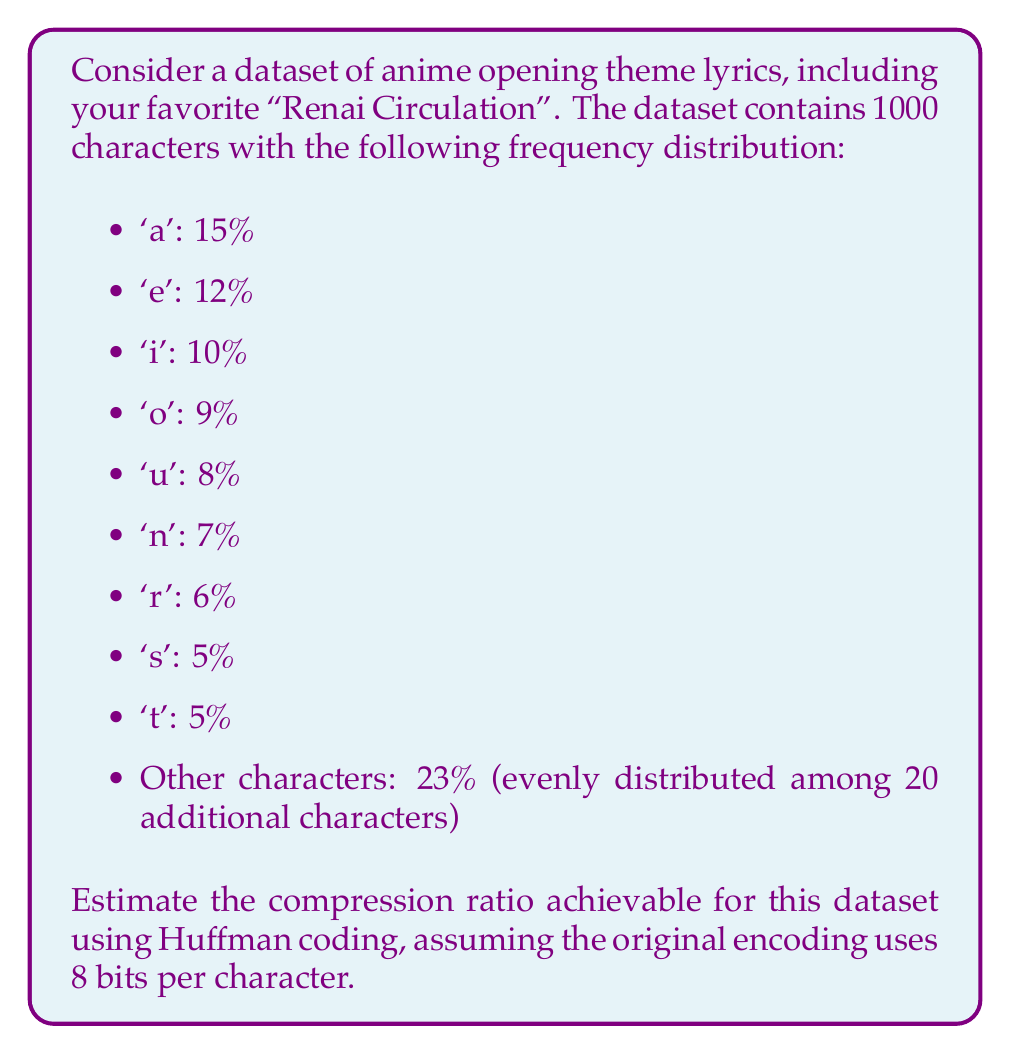Could you help me with this problem? To solve this problem, we'll follow these steps:

1. Calculate the entropy of the dataset
2. Estimate the average codeword length using Huffman coding
3. Calculate the compression ratio

Step 1: Calculate the entropy

The entropy $H$ of the dataset is given by:

$$H = -\sum_{i=1}^{n} p_i \log_2(p_i)$$

Where $p_i$ is the probability of each character.

$$\begin{align}
H &= -(0.15 \log_2(0.15) + 0.12 \log_2(0.12) + 0.10 \log_2(0.10) + 0.09 \log_2(0.09) + 0.08 \log_2(0.08) \\
&+ 0.07 \log_2(0.07) + 0.06 \log_2(0.06) + 0.05 \log_2(0.05) + 0.05 \log_2(0.05) + 20 \cdot (0.0115 \log_2(0.0115))) \\
&\approx 4.14 \text{ bits}
\end{align}$$

Step 2: Estimate average codeword length

For Huffman coding, the average codeword length is typically within 1 bit of the entropy. We'll estimate it as $H + 0.5$:

Average codeword length $\approx 4.14 + 0.5 = 4.64$ bits

Step 3: Calculate compression ratio

The compression ratio is calculated as:

$$\text{Compression Ratio} = \frac{\text{Original size}}{\text{Compressed size}}$$

Original size: 8 bits/character
Compressed size: 4.64 bits/character (estimated)

$$\text{Compression Ratio} = \frac{8}{4.64} \approx 1.72$$
Answer: The estimated compression ratio achievable for the dataset of anime opening theme lyrics using Huffman coding is approximately 1.72:1. 